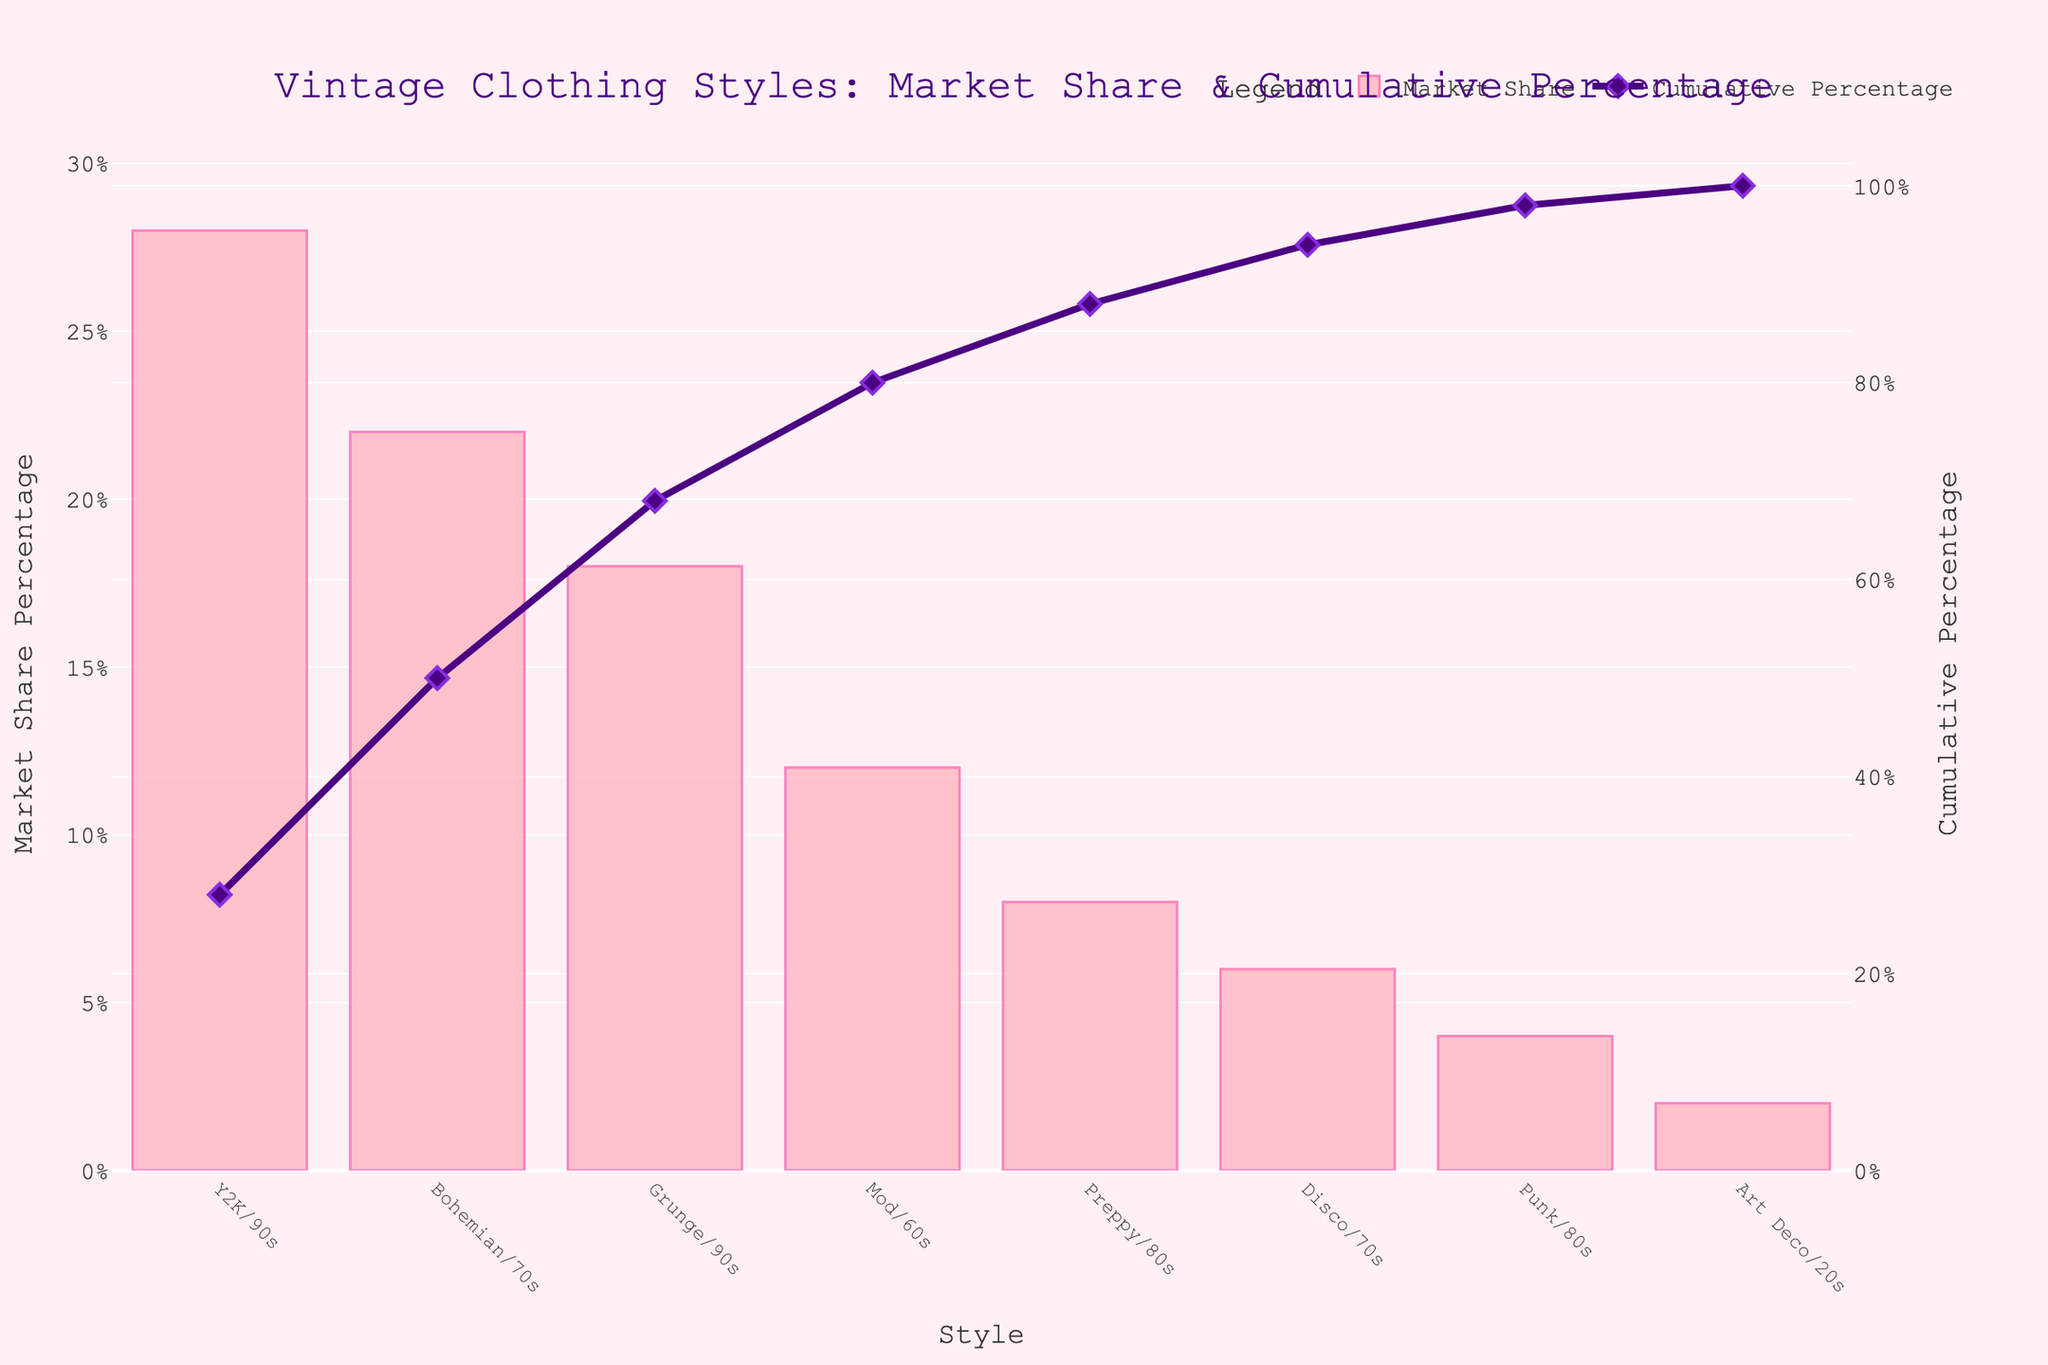what is the title of the figure? Look at the top of the plot where the main heading is displayed in large font. The title should be clearly visible there.
Answer: "Vintage Clothing Styles: Market Share & Cumulative Percentage" how many total vintage clothing styles are represented? Count the number of unique bars and markers along the x-axis, each representing a different style.
Answer: 8 Which vintage clothing style has the highest market share? Identify the bar that reaches the highest value on the y-axis labeled "Market Share Percentage".
Answer: Y2K/90s what is the cumulative percentage after three most popular styles? Sum the market share percentages of the top three styles and look at their corresponding points in the cumulative percentage line plot.
Answer: 68% how does the market share percentage of Grunge/90s compare to Bohemian/70s? Find the bar heights for Grunge/90s and Bohemian/70s on the y-axis labeled "Market Share Percentage" and compare them directly.
Answer: Grunge/90s is 4 percentage points lower than Bohemian/70s which style contributes exactly 2% to the market share? Find the bar whose height corresponds to 2% on the y-axis labeled "Market Share Percentage".
Answer: Art Deco/20s What is the cumulative market share percentage for the styles Mod/60s and Disco/70s combined? Add the market share percentages of Mod/60s and Disco/70s and then find the cumulative percentage at Disco/70s.
Answer: 88% What percentage of the market share do the styles from the 70s (Bohemian, Disco) contribute together? Look up the market share percentages of Bohemian/70s and Disco/70s and sum them up (22% + 6%).
Answer: 28% what is the second least popular vintage clothing style? Identify the style with the second smallest bar in the figure.
Answer: Punk/80s how does the cumulative percentage change from Preppy/80s to Disco/70s? Check the cumulative percentage values at Preppy/80s and Disco/70s and subtract the former from the latter to find the change.
Answer: 18% 